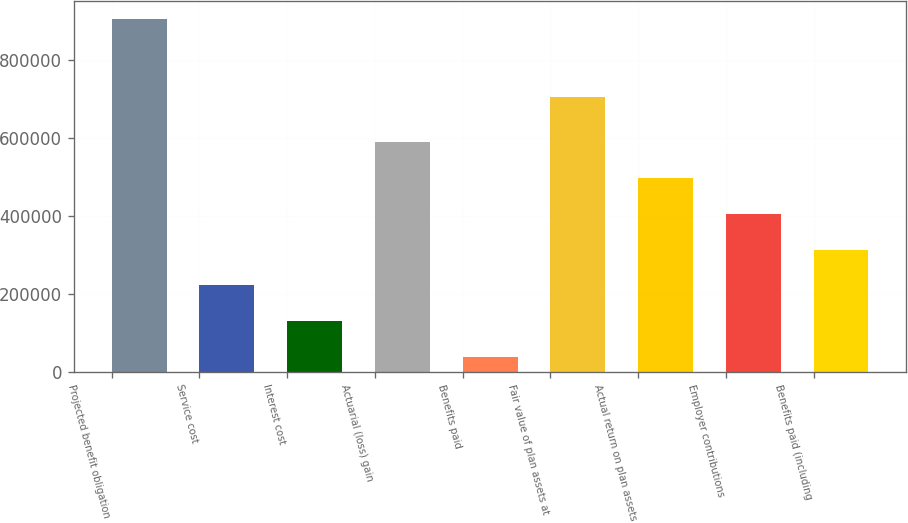Convert chart to OTSL. <chart><loc_0><loc_0><loc_500><loc_500><bar_chart><fcel>Projected benefit obligation<fcel>Service cost<fcel>Interest cost<fcel>Actuarial (loss) gain<fcel>Benefits paid<fcel>Fair value of plan assets at<fcel>Actual return on plan assets<fcel>Employer contributions<fcel>Benefits paid (including<nl><fcel>905943<fcel>221653<fcel>129838<fcel>588912<fcel>38023<fcel>704976<fcel>497098<fcel>405283<fcel>313468<nl></chart> 